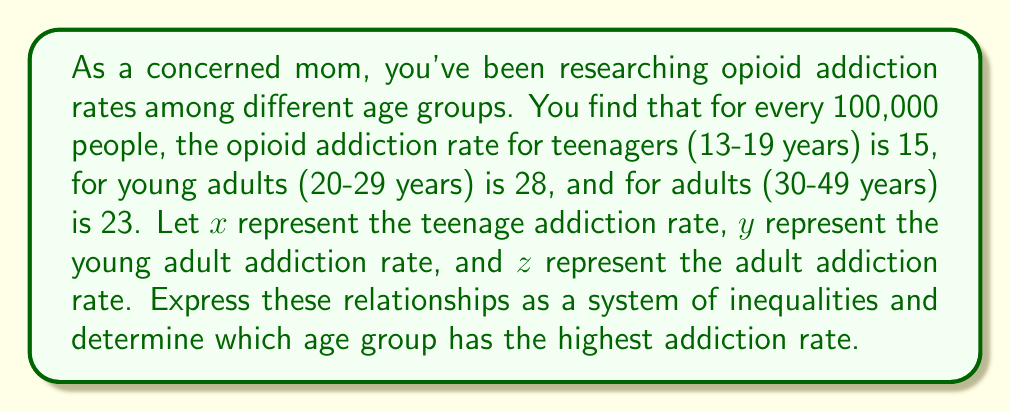Provide a solution to this math problem. To solve this problem, we need to express the given information as inequalities and then compare them:

1. Let's define our variables:
   $x$ = teenage addiction rate (13-19 years)
   $y$ = young adult addiction rate (20-29 years)
   $z$ = adult addiction rate (30-49 years)

2. Express the given information as inequalities:
   $x = 15$
   $y = 28$
   $z = 23$

3. To compare these rates, we can set up the following inequalities:
   $x < z < y$

4. Substituting the values:
   $15 < 23 < 28$

5. This inequality holds true, confirming our arrangement.

6. To determine which age group has the highest addiction rate, we look at the largest value in our inequality:
   $y = 28$ is the largest value, corresponding to the young adult age group (20-29 years).
Answer: The young adult age group (20-29 years) has the highest opioid addiction rate at 28 per 100,000 people. 